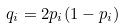<formula> <loc_0><loc_0><loc_500><loc_500>q _ { i } = 2 p _ { i } ( 1 - p _ { i } )</formula> 